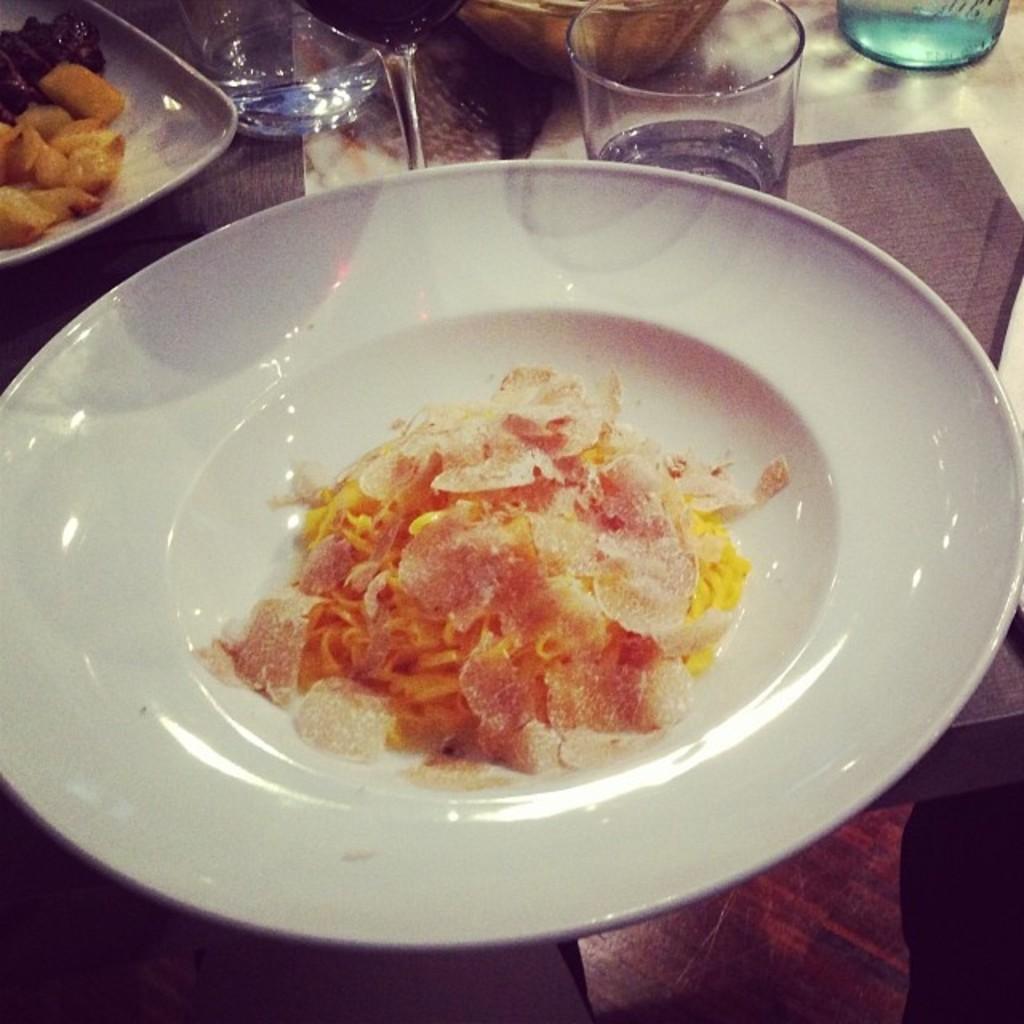Please provide a concise description of this image. In this image there are food items on the plates , glasses and an object on the table. 